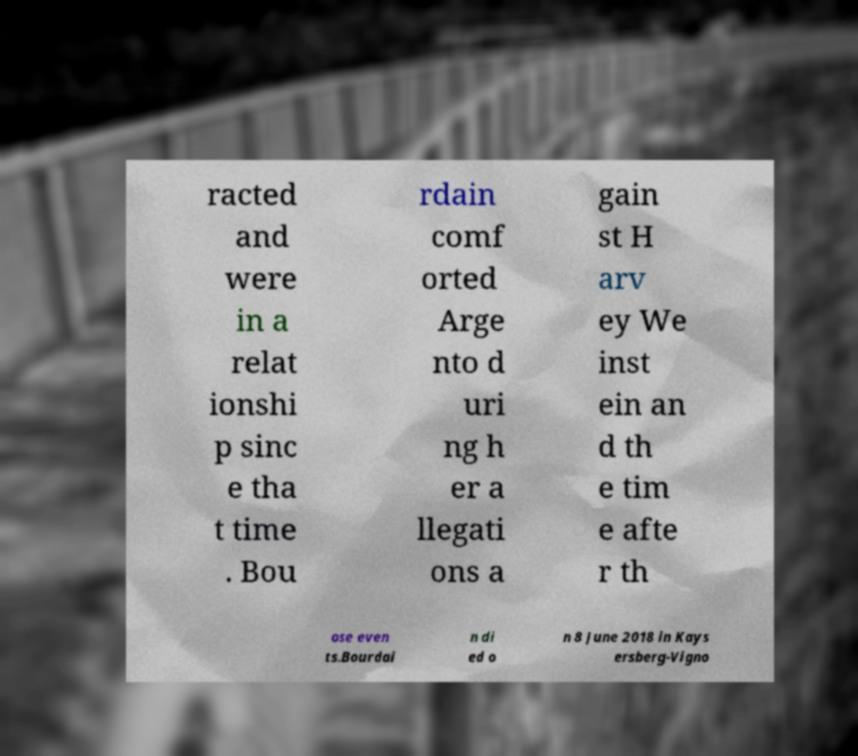For documentation purposes, I need the text within this image transcribed. Could you provide that? racted and were in a relat ionshi p sinc e tha t time . Bou rdain comf orted Arge nto d uri ng h er a llegati ons a gain st H arv ey We inst ein an d th e tim e afte r th ose even ts.Bourdai n di ed o n 8 June 2018 in Kays ersberg-Vigno 